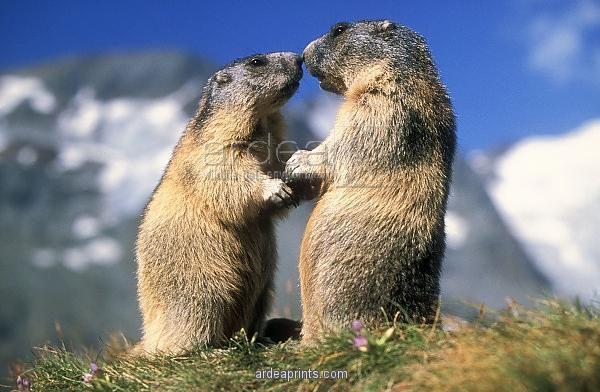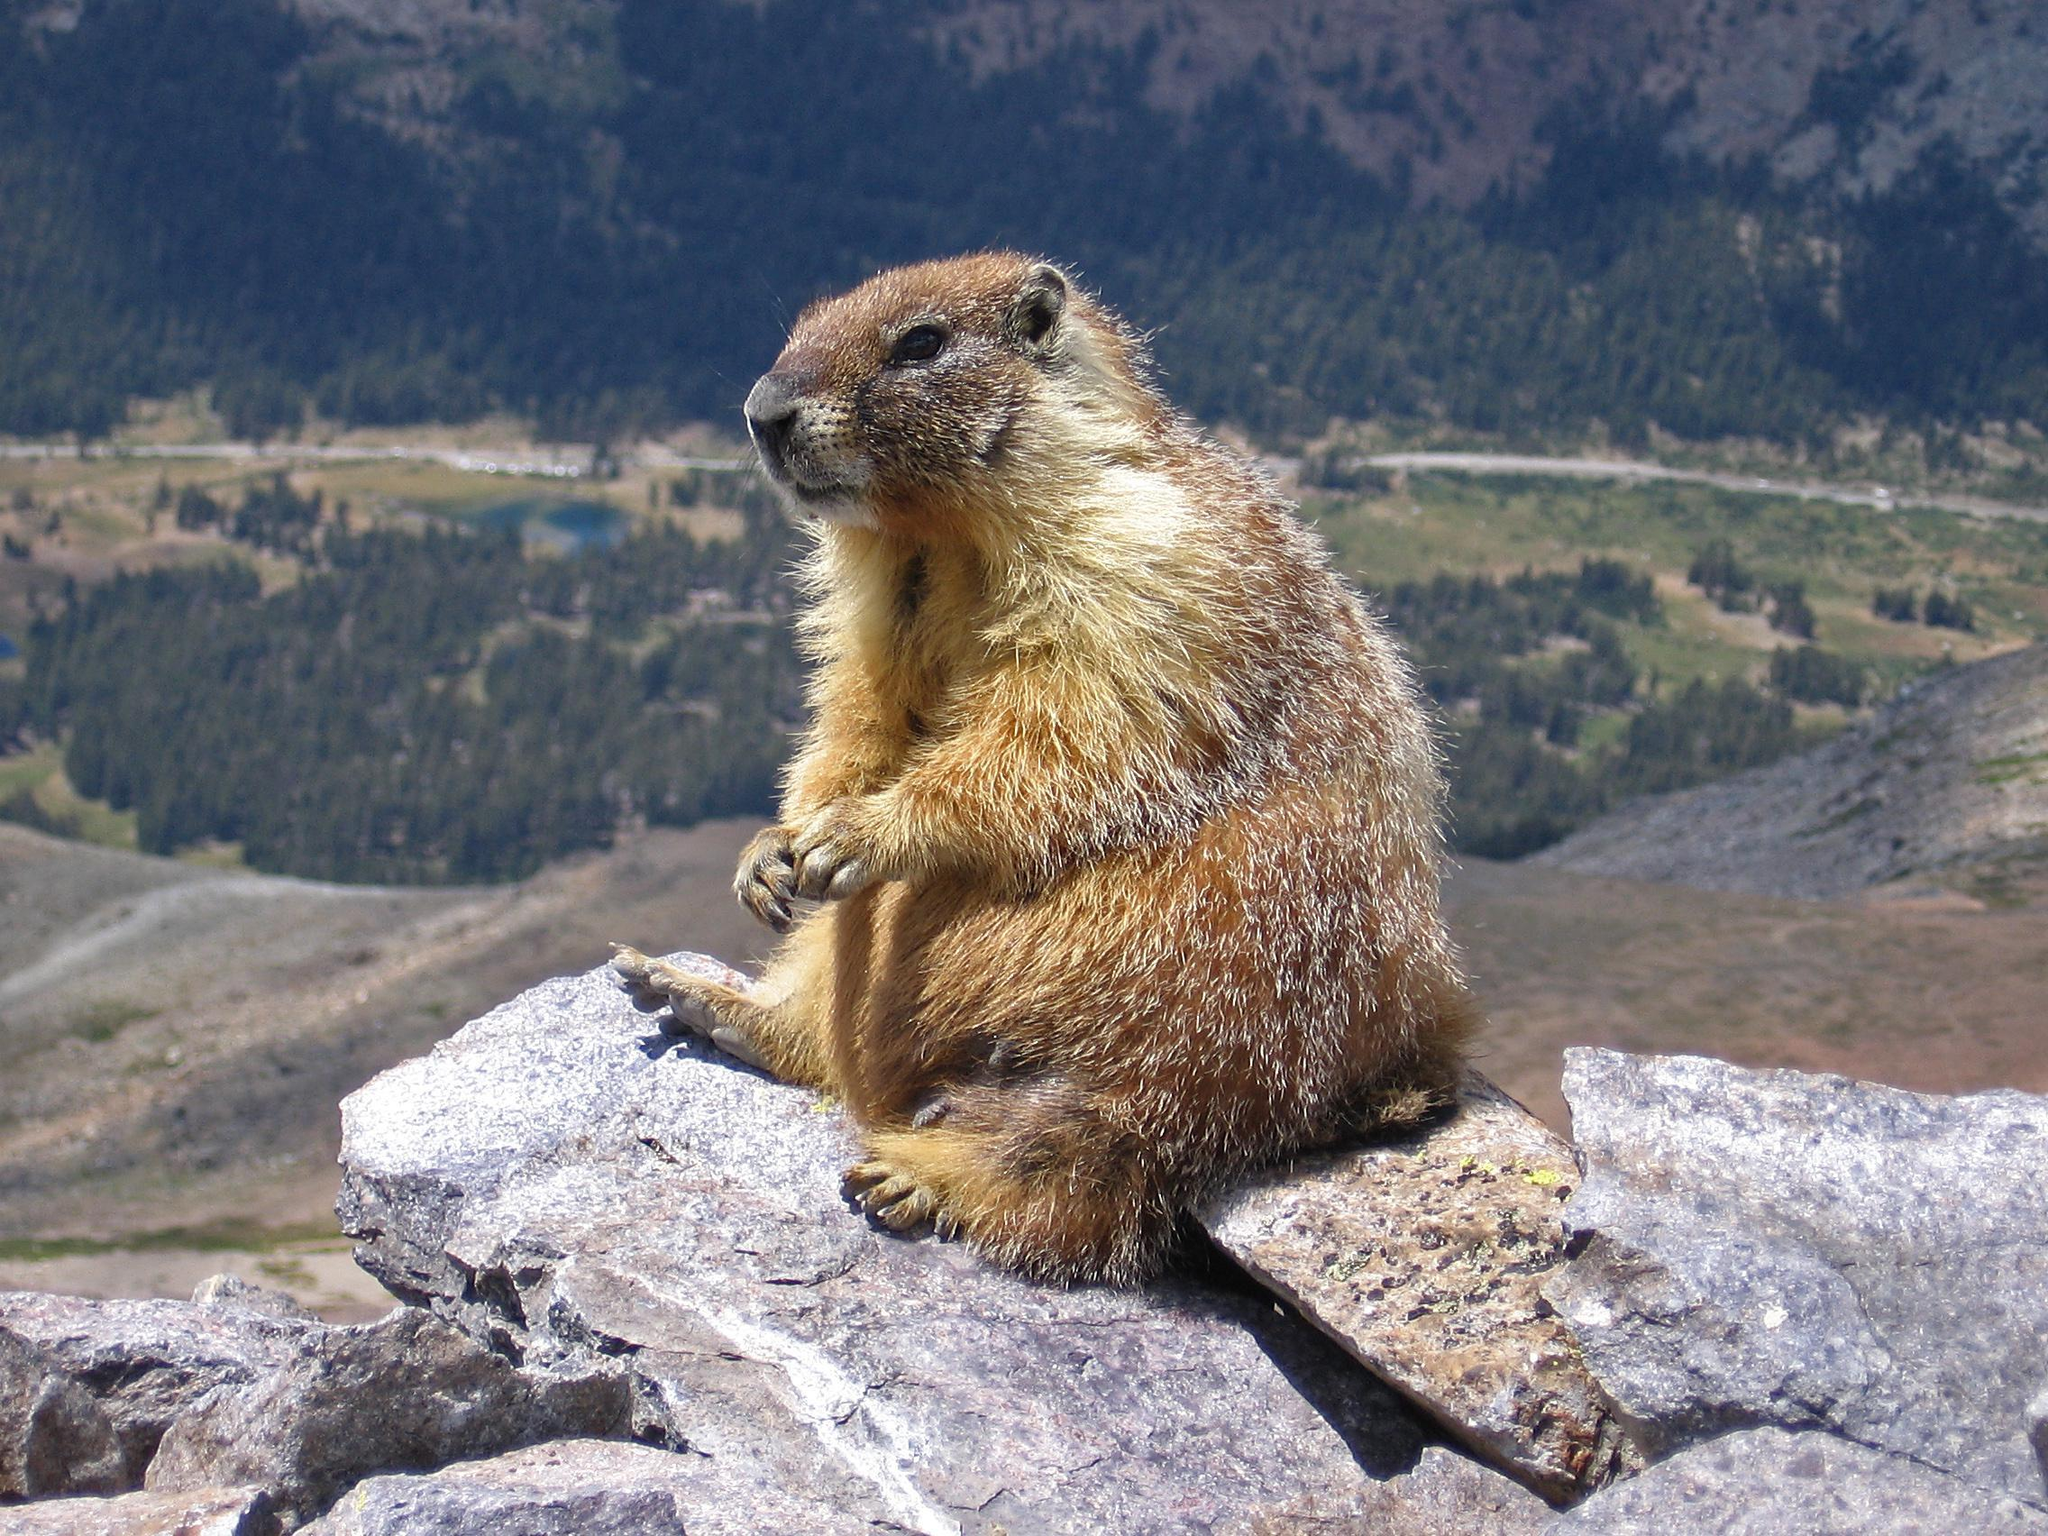The first image is the image on the left, the second image is the image on the right. Considering the images on both sides, is "In the right image there are two rodents facing towards the right." valid? Answer yes or no. No. The first image is the image on the left, the second image is the image on the right. Considering the images on both sides, is "There are two marmots in the right image, and three on the left" valid? Answer yes or no. No. 